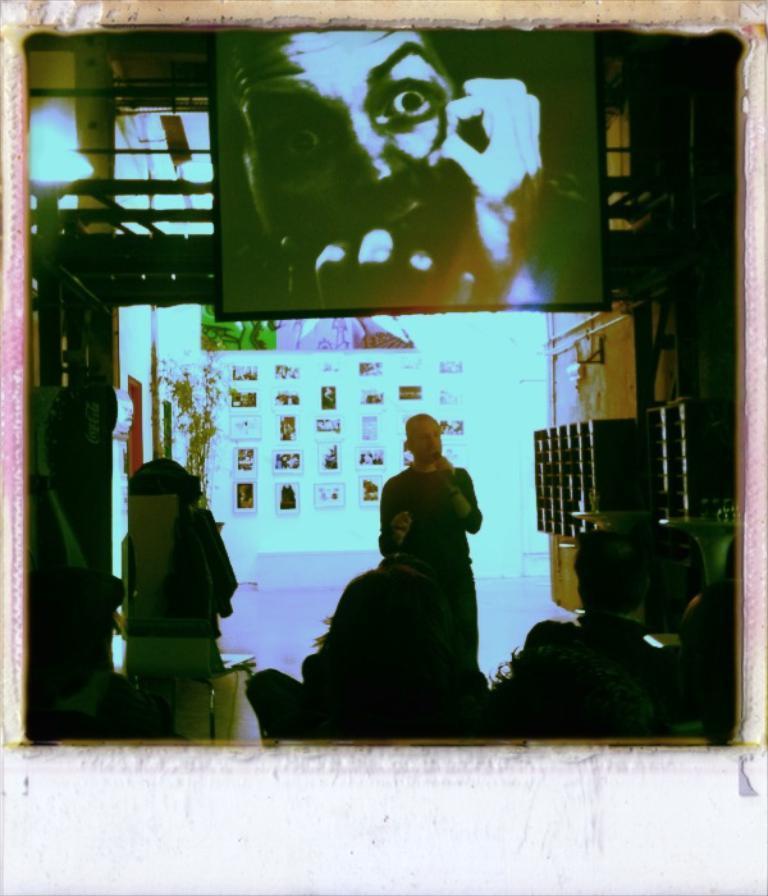In one or two sentences, can you explain what this image depicts? As we can see in the image there is a wall, photo frames, screen and few people here and there. 